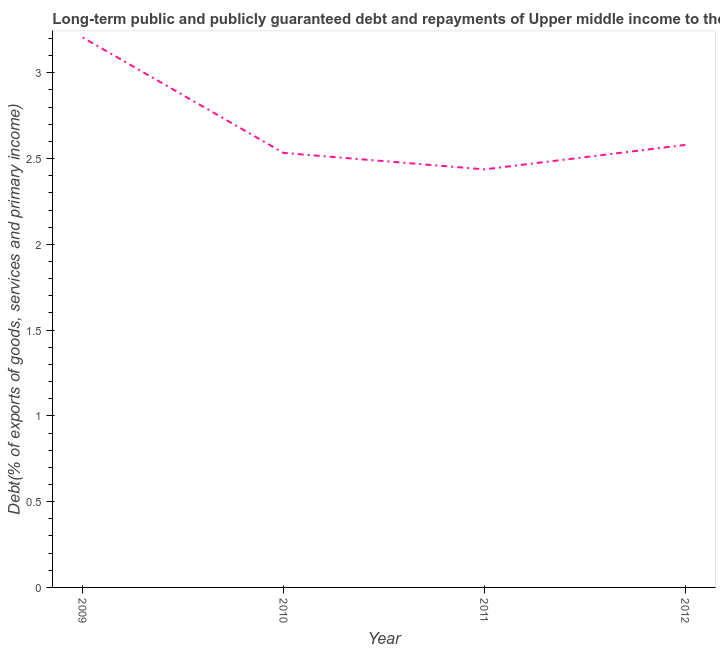What is the debt service in 2012?
Ensure brevity in your answer.  2.58. Across all years, what is the maximum debt service?
Provide a short and direct response. 3.21. Across all years, what is the minimum debt service?
Ensure brevity in your answer.  2.44. What is the sum of the debt service?
Provide a succinct answer. 10.76. What is the difference between the debt service in 2011 and 2012?
Give a very brief answer. -0.14. What is the average debt service per year?
Provide a short and direct response. 2.69. What is the median debt service?
Keep it short and to the point. 2.56. Do a majority of the years between 2010 and 2012 (inclusive) have debt service greater than 2.4 %?
Provide a short and direct response. Yes. What is the ratio of the debt service in 2009 to that in 2011?
Ensure brevity in your answer.  1.32. What is the difference between the highest and the second highest debt service?
Ensure brevity in your answer.  0.63. Is the sum of the debt service in 2009 and 2012 greater than the maximum debt service across all years?
Your response must be concise. Yes. What is the difference between the highest and the lowest debt service?
Make the answer very short. 0.77. In how many years, is the debt service greater than the average debt service taken over all years?
Your response must be concise. 1. How many lines are there?
Your response must be concise. 1. Are the values on the major ticks of Y-axis written in scientific E-notation?
Your response must be concise. No. Does the graph contain any zero values?
Keep it short and to the point. No. Does the graph contain grids?
Offer a very short reply. No. What is the title of the graph?
Offer a terse response. Long-term public and publicly guaranteed debt and repayments of Upper middle income to the IMF. What is the label or title of the Y-axis?
Your response must be concise. Debt(% of exports of goods, services and primary income). What is the Debt(% of exports of goods, services and primary income) in 2009?
Give a very brief answer. 3.21. What is the Debt(% of exports of goods, services and primary income) of 2010?
Make the answer very short. 2.53. What is the Debt(% of exports of goods, services and primary income) in 2011?
Ensure brevity in your answer.  2.44. What is the Debt(% of exports of goods, services and primary income) in 2012?
Your response must be concise. 2.58. What is the difference between the Debt(% of exports of goods, services and primary income) in 2009 and 2010?
Your answer should be very brief. 0.67. What is the difference between the Debt(% of exports of goods, services and primary income) in 2009 and 2011?
Your response must be concise. 0.77. What is the difference between the Debt(% of exports of goods, services and primary income) in 2009 and 2012?
Offer a terse response. 0.63. What is the difference between the Debt(% of exports of goods, services and primary income) in 2010 and 2011?
Make the answer very short. 0.1. What is the difference between the Debt(% of exports of goods, services and primary income) in 2010 and 2012?
Your answer should be compact. -0.05. What is the difference between the Debt(% of exports of goods, services and primary income) in 2011 and 2012?
Your answer should be very brief. -0.14. What is the ratio of the Debt(% of exports of goods, services and primary income) in 2009 to that in 2010?
Make the answer very short. 1.27. What is the ratio of the Debt(% of exports of goods, services and primary income) in 2009 to that in 2011?
Keep it short and to the point. 1.32. What is the ratio of the Debt(% of exports of goods, services and primary income) in 2009 to that in 2012?
Make the answer very short. 1.24. What is the ratio of the Debt(% of exports of goods, services and primary income) in 2010 to that in 2011?
Make the answer very short. 1.04. What is the ratio of the Debt(% of exports of goods, services and primary income) in 2010 to that in 2012?
Your answer should be compact. 0.98. What is the ratio of the Debt(% of exports of goods, services and primary income) in 2011 to that in 2012?
Offer a terse response. 0.94. 